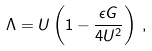Convert formula to latex. <formula><loc_0><loc_0><loc_500><loc_500>\Lambda = U \left ( 1 - \frac { \epsilon G } { 4 U ^ { 2 } } \right ) \, ,</formula> 